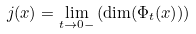Convert formula to latex. <formula><loc_0><loc_0><loc_500><loc_500>j ( x ) = \lim _ { t \rightarrow 0 - } \left ( \dim ( \Phi _ { t } ( x ) ) \right )</formula> 